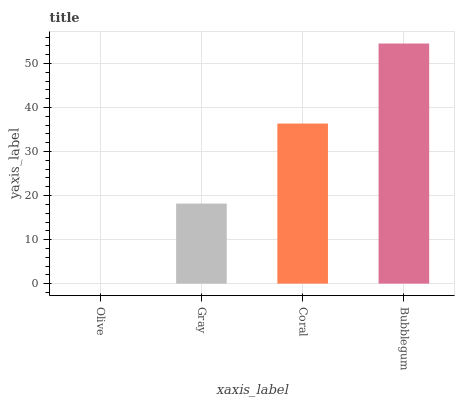Is Gray the minimum?
Answer yes or no. No. Is Gray the maximum?
Answer yes or no. No. Is Gray greater than Olive?
Answer yes or no. Yes. Is Olive less than Gray?
Answer yes or no. Yes. Is Olive greater than Gray?
Answer yes or no. No. Is Gray less than Olive?
Answer yes or no. No. Is Coral the high median?
Answer yes or no. Yes. Is Gray the low median?
Answer yes or no. Yes. Is Olive the high median?
Answer yes or no. No. Is Bubblegum the low median?
Answer yes or no. No. 